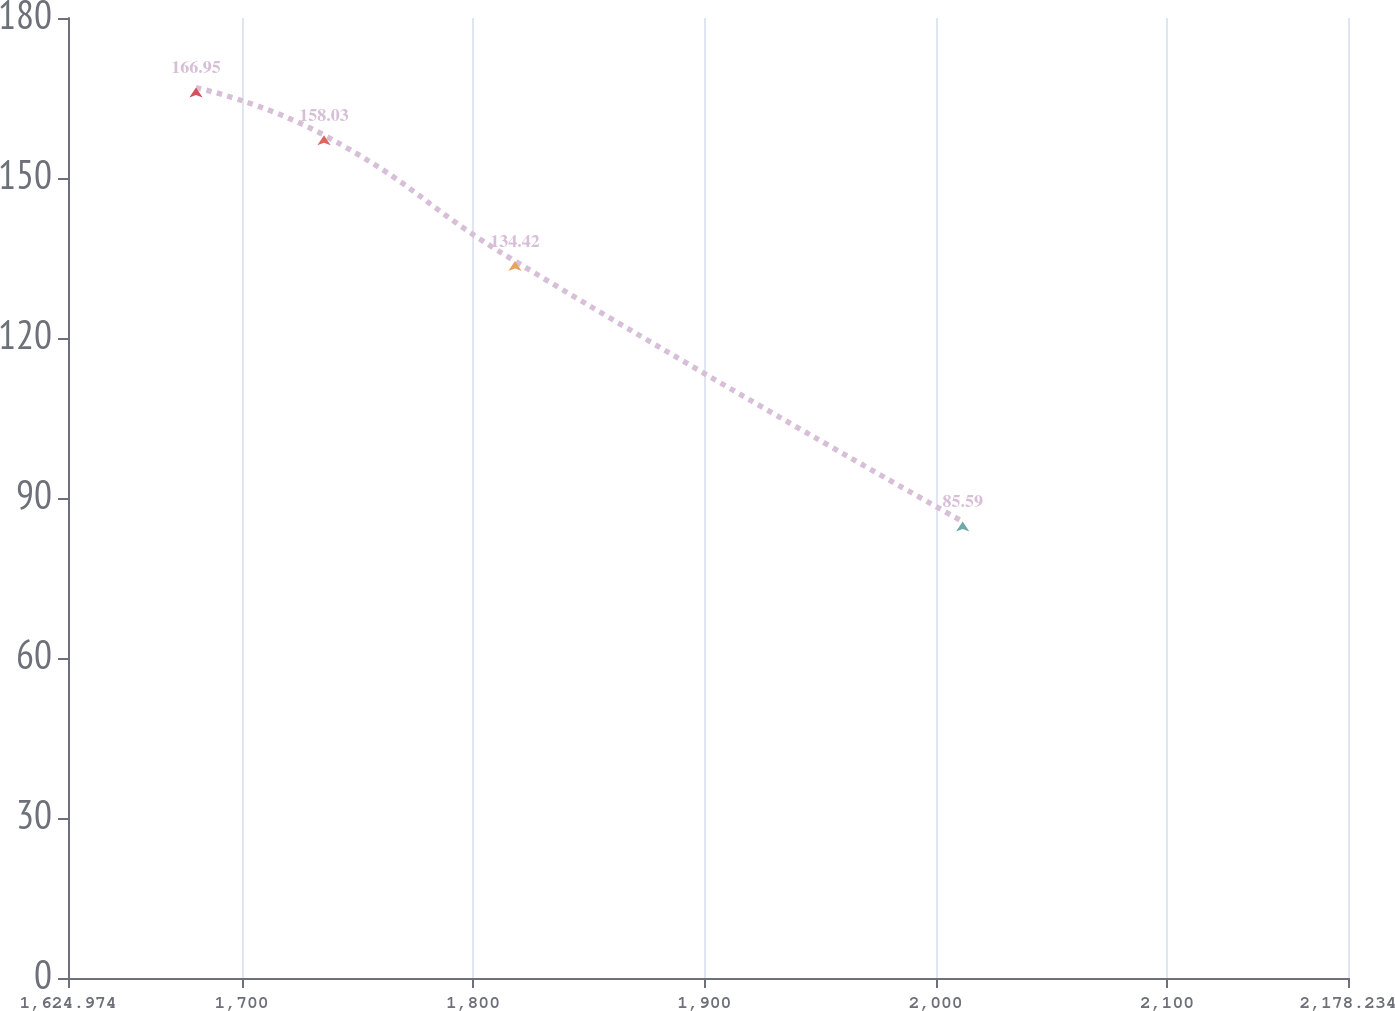Convert chart to OTSL. <chart><loc_0><loc_0><loc_500><loc_500><line_chart><ecel><fcel>Unnamed: 1<nl><fcel>1680.3<fcel>166.95<nl><fcel>1735.63<fcel>158.03<nl><fcel>1818.18<fcel>134.42<nl><fcel>2011.69<fcel>85.59<nl><fcel>2233.56<fcel>76.67<nl></chart> 